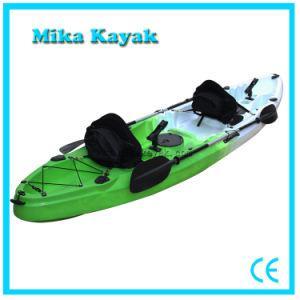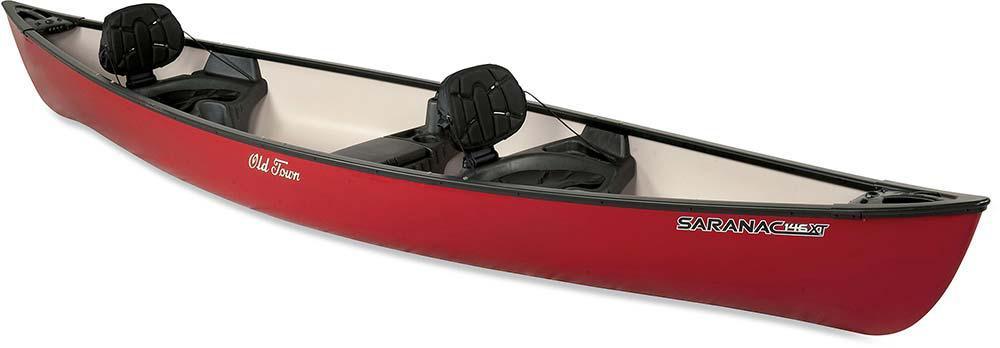The first image is the image on the left, the second image is the image on the right. Considering the images on both sides, is "there are 6 seats in the canoe  in the image pair" valid? Answer yes or no. No. The first image is the image on the left, the second image is the image on the right. For the images displayed, is the sentence "the right side pic has a boat with seats that have back rests" factually correct? Answer yes or no. Yes. 